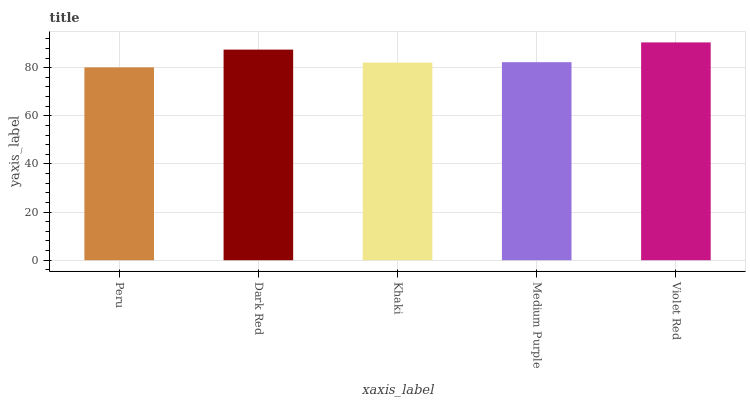Is Peru the minimum?
Answer yes or no. Yes. Is Violet Red the maximum?
Answer yes or no. Yes. Is Dark Red the minimum?
Answer yes or no. No. Is Dark Red the maximum?
Answer yes or no. No. Is Dark Red greater than Peru?
Answer yes or no. Yes. Is Peru less than Dark Red?
Answer yes or no. Yes. Is Peru greater than Dark Red?
Answer yes or no. No. Is Dark Red less than Peru?
Answer yes or no. No. Is Medium Purple the high median?
Answer yes or no. Yes. Is Medium Purple the low median?
Answer yes or no. Yes. Is Peru the high median?
Answer yes or no. No. Is Peru the low median?
Answer yes or no. No. 